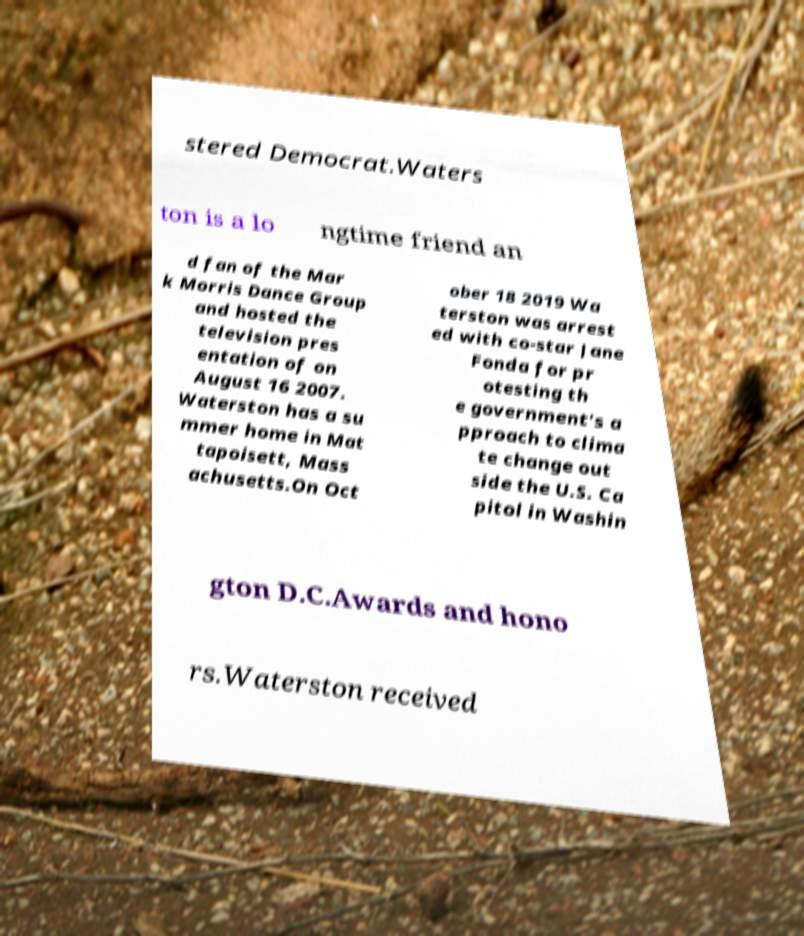There's text embedded in this image that I need extracted. Can you transcribe it verbatim? stered Democrat.Waters ton is a lo ngtime friend an d fan of the Mar k Morris Dance Group and hosted the television pres entation of on August 16 2007. Waterston has a su mmer home in Mat tapoisett, Mass achusetts.On Oct ober 18 2019 Wa terston was arrest ed with co-star Jane Fonda for pr otesting th e government's a pproach to clima te change out side the U.S. Ca pitol in Washin gton D.C.Awards and hono rs.Waterston received 